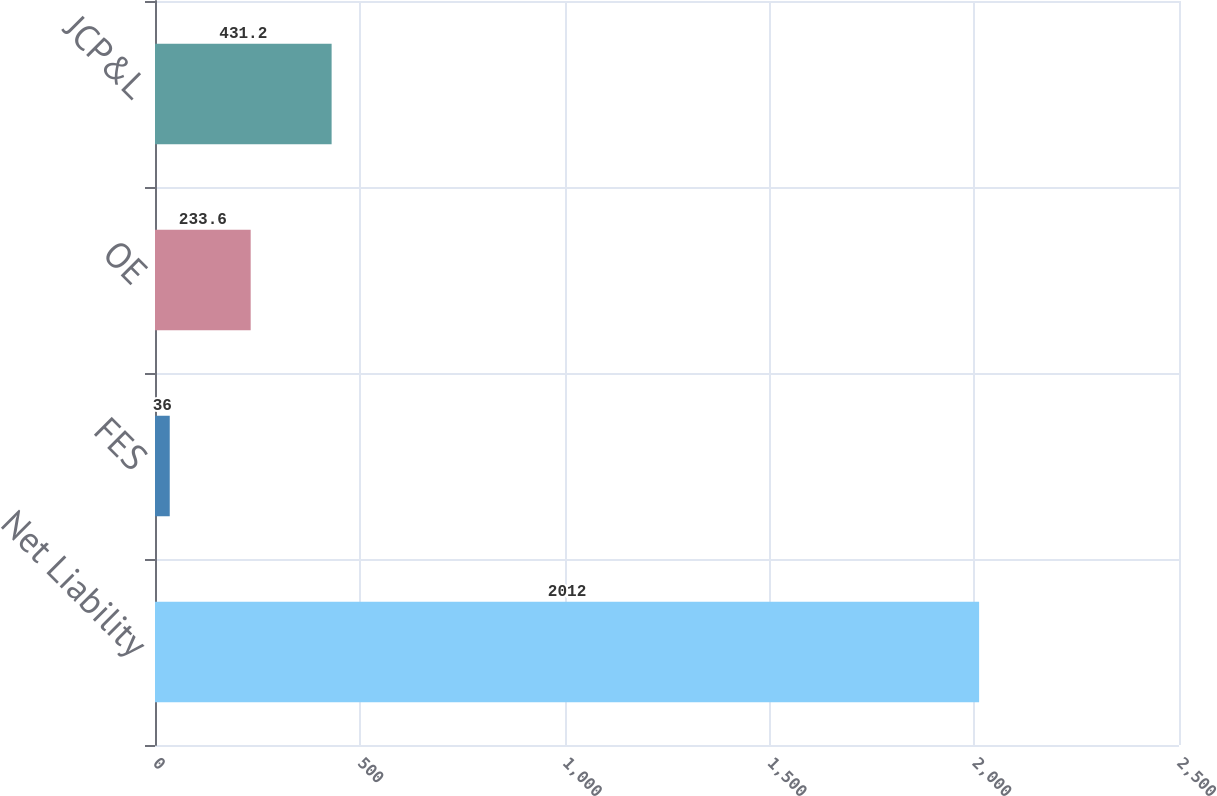Convert chart. <chart><loc_0><loc_0><loc_500><loc_500><bar_chart><fcel>Net Liability<fcel>FES<fcel>OE<fcel>JCP&L<nl><fcel>2012<fcel>36<fcel>233.6<fcel>431.2<nl></chart> 